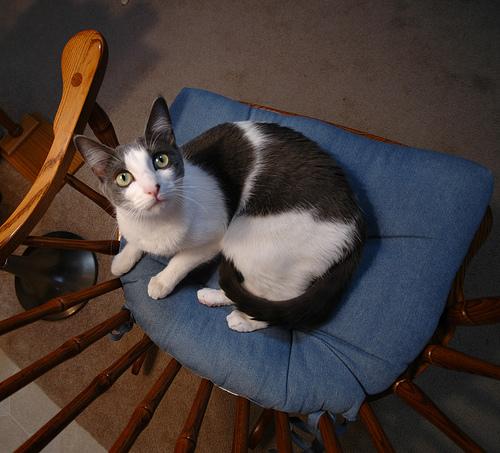Is this cat hungry?
Concise answer only. Yes. Is the cat standing or sitting?
Short answer required. Sitting. Is the cat on it's belly?
Be succinct. Yes. What is the cat looking at?
Short answer required. Camera. 